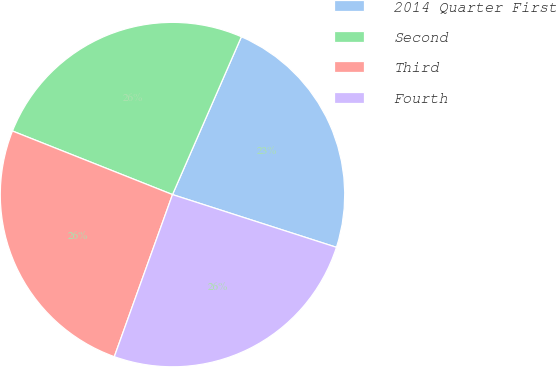Convert chart to OTSL. <chart><loc_0><loc_0><loc_500><loc_500><pie_chart><fcel>2014 Quarter First<fcel>Second<fcel>Third<fcel>Fourth<nl><fcel>23.4%<fcel>25.53%<fcel>25.53%<fcel>25.53%<nl></chart> 